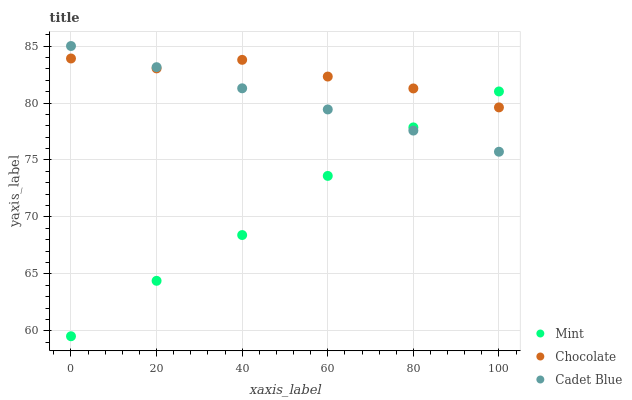Does Mint have the minimum area under the curve?
Answer yes or no. Yes. Does Chocolate have the maximum area under the curve?
Answer yes or no. Yes. Does Chocolate have the minimum area under the curve?
Answer yes or no. No. Does Mint have the maximum area under the curve?
Answer yes or no. No. Is Cadet Blue the smoothest?
Answer yes or no. Yes. Is Chocolate the roughest?
Answer yes or no. Yes. Is Mint the smoothest?
Answer yes or no. No. Is Mint the roughest?
Answer yes or no. No. Does Mint have the lowest value?
Answer yes or no. Yes. Does Chocolate have the lowest value?
Answer yes or no. No. Does Cadet Blue have the highest value?
Answer yes or no. Yes. Does Chocolate have the highest value?
Answer yes or no. No. Does Chocolate intersect Mint?
Answer yes or no. Yes. Is Chocolate less than Mint?
Answer yes or no. No. Is Chocolate greater than Mint?
Answer yes or no. No. 